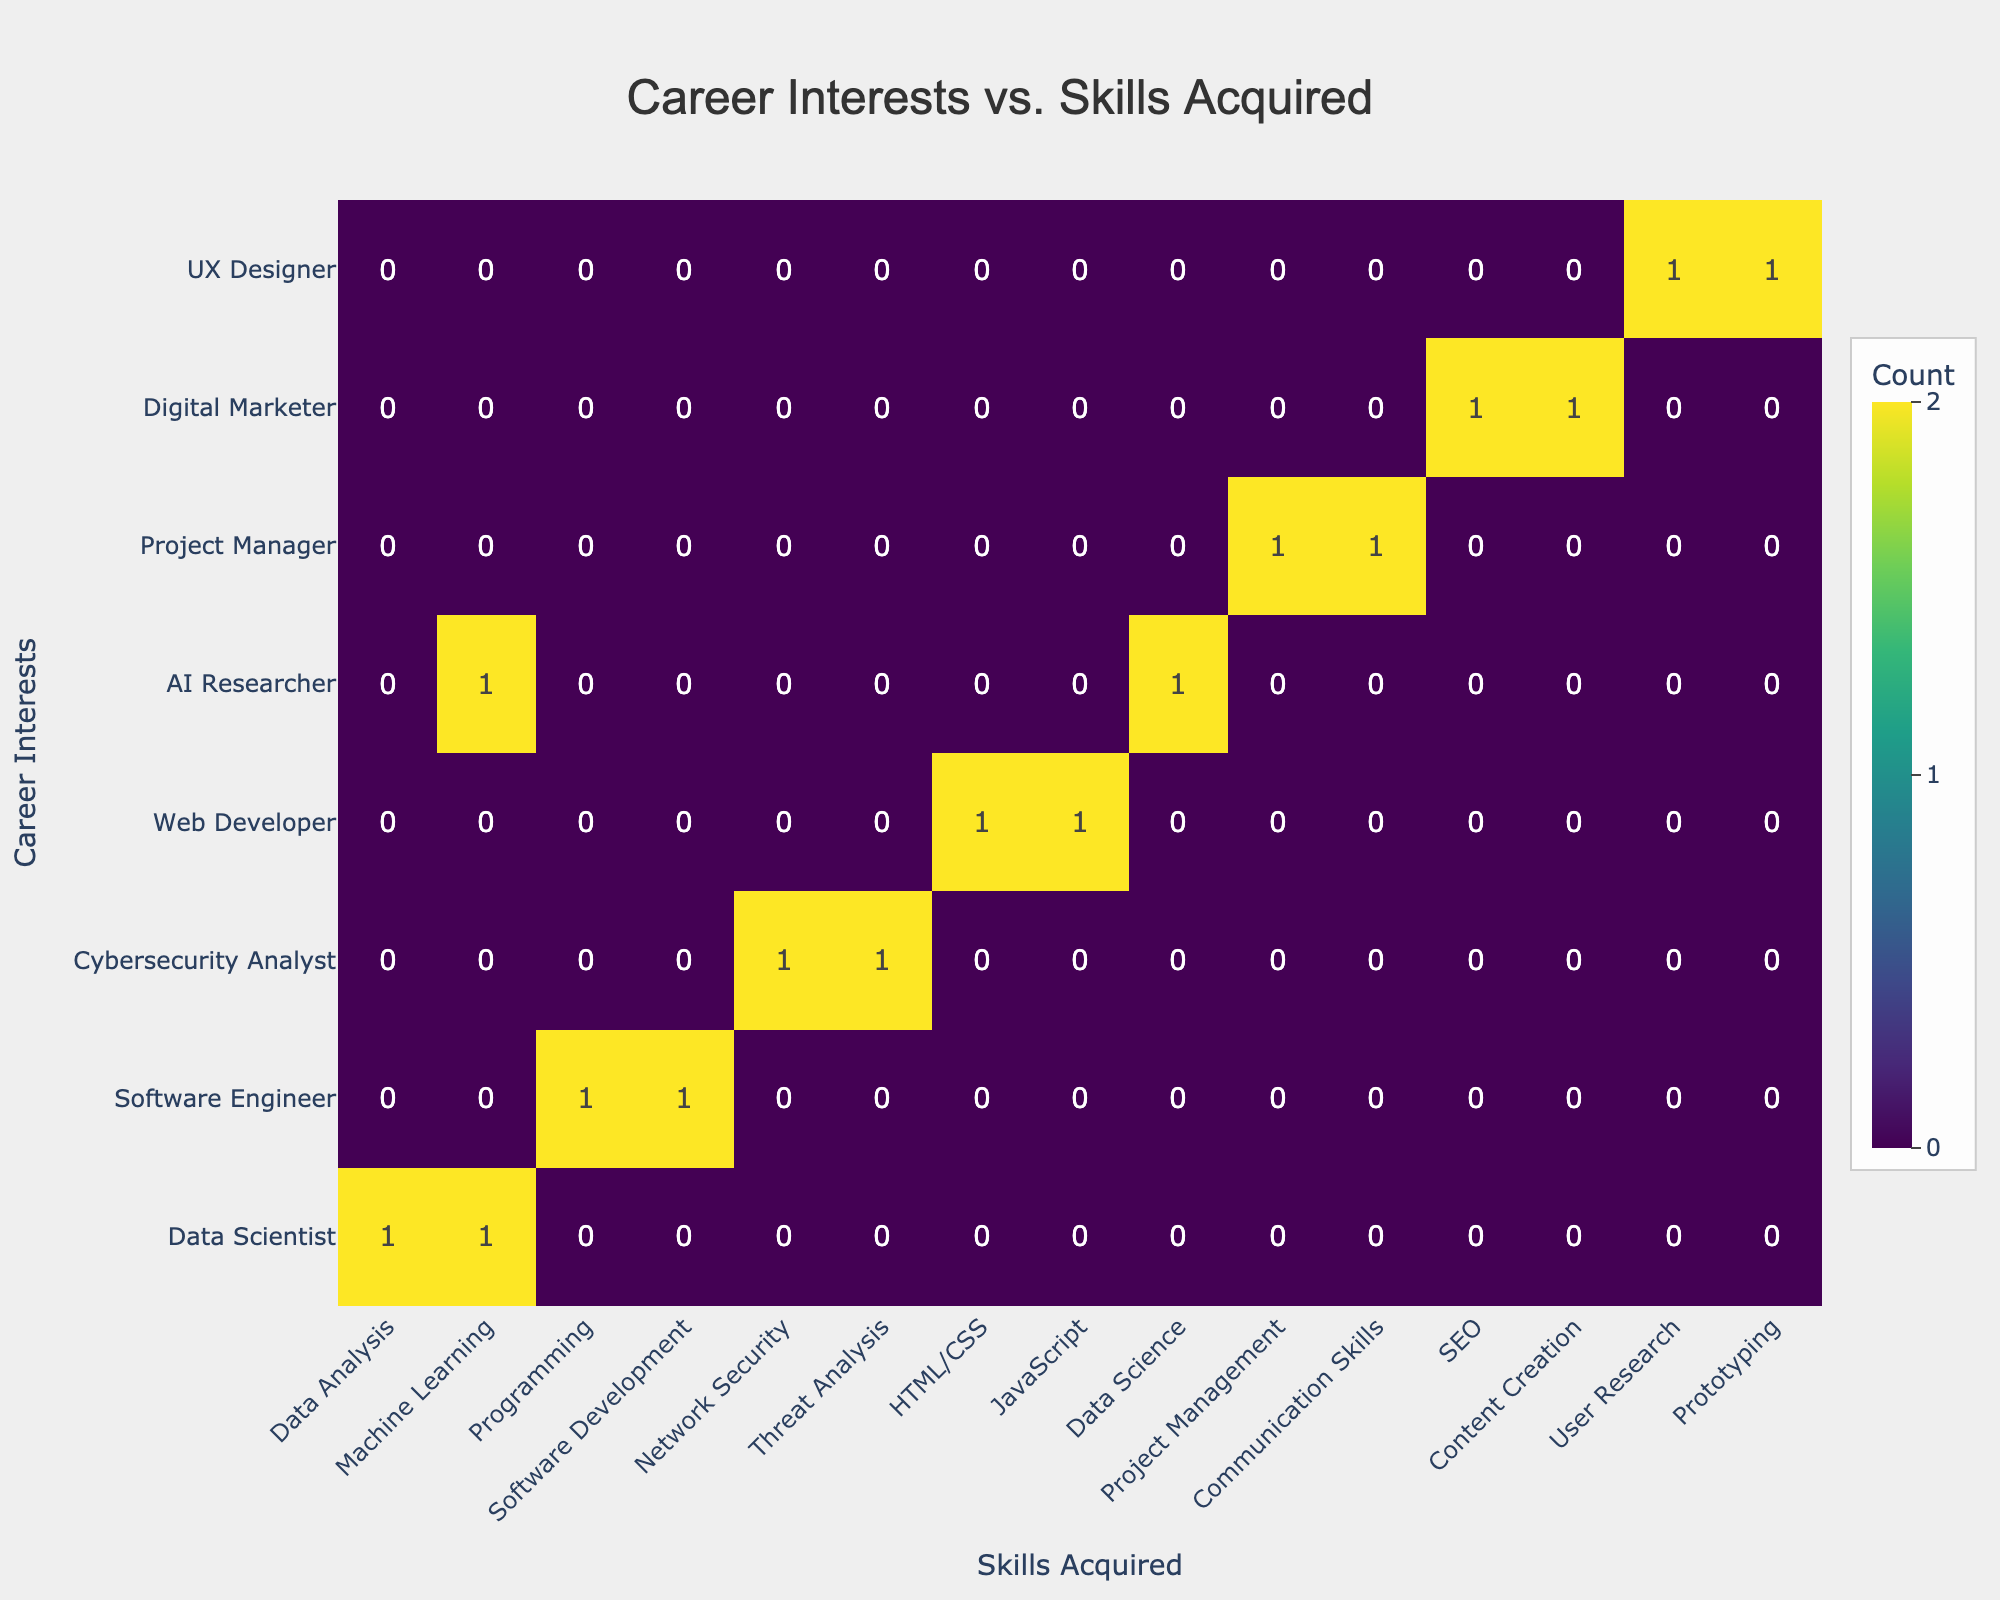What is the skill acquired most frequently by students interested in becoming a Software Engineer? The confusion matrix shows that the skills listed under Software Engineer are Programming and Software Development. Both skills have a count of 1; hence, they are equally the most frequent.
Answer: Programming and Software Development How many different skills have been acquired related to Cybersecurity Analyst? According to the table, there are two skills related to Cybersecurity Analyst: Network Security and Threat Analysis. Both have a count of 1. Therefore, the total number of different skills acquired for this career interest is 2.
Answer: 2 Do students interested in Digital Marketing acquire either SEO or Content Creation skills? Both SEO and Content Creation skills are listed under Digital Marketer with a count of 1 for each, indicating that students interested in Digital Marketing do indeed acquire these skills.
Answer: Yes Which career interest has the maximum number of skills acquired? Students interested in AI Researcher have both Machine Learning and Data Science as skills acquired, totaling 2 skills. Other career interests like Software Engineer and Digital Marketer each have only 1 skill. Therefore, AI Researcher has the maximum number of skills acquired.
Answer: AI Researcher Are there any students interested in UX Designer who acquire skills in Machine Learning? The confusion matrix lists the skills for UX Designer as User Research and Prototyping, with no indication of Machine Learning being a skill acquired by this career interest. Thus, there are no students interested in this area who acquire skills in Machine Learning.
Answer: No 